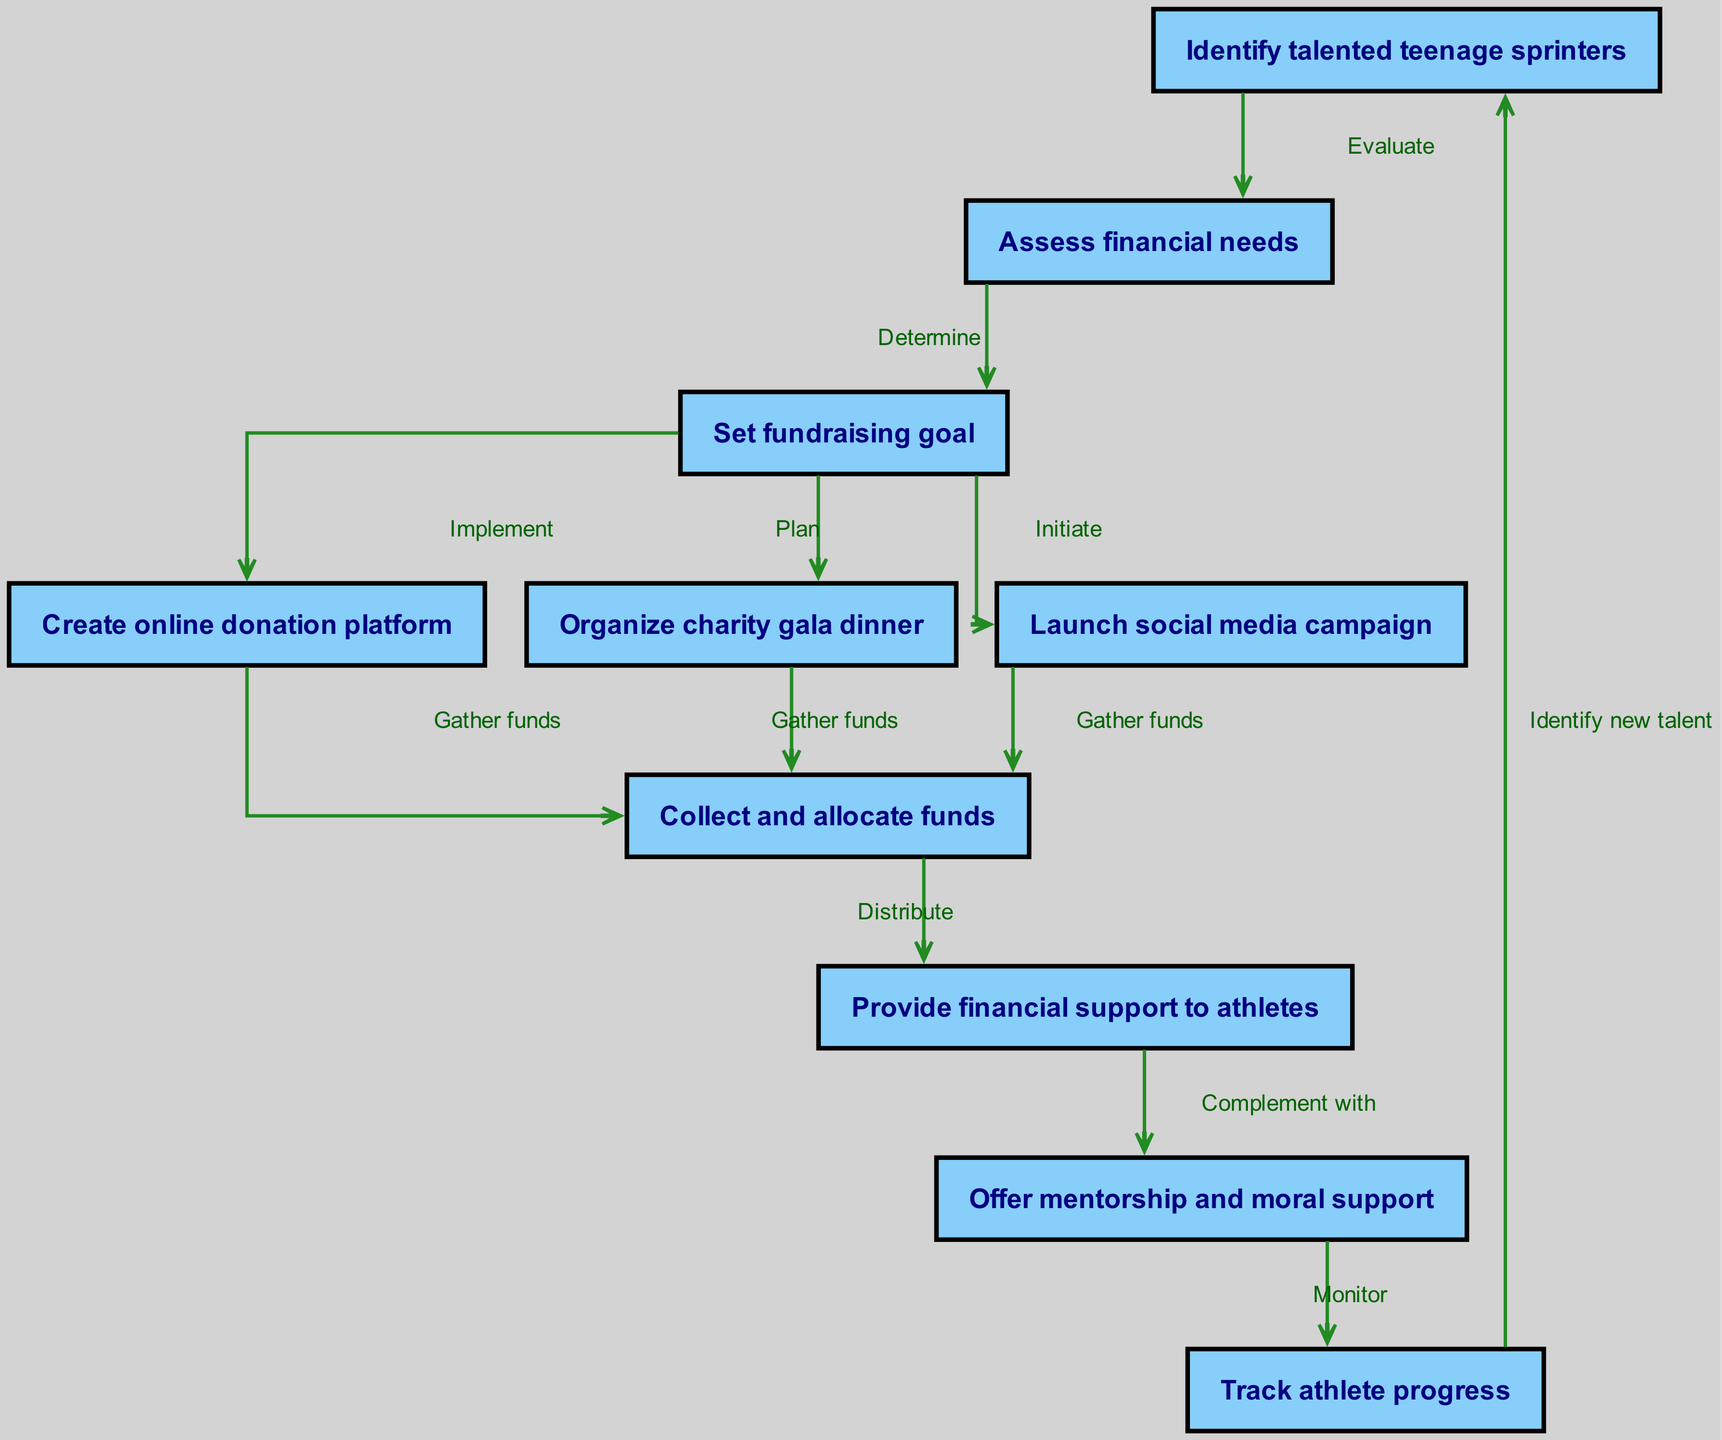What is the first step in the fundraising campaign workflow? The first node in the diagram is "Identify talented teenage sprinters," which indicates that this is the initial action in the workflow.
Answer: Identify talented teenage sprinters How many nodes are there in the diagram? By counting the provided nodes, there are a total of 10 nodes listed, representing different stages or actions in the fundraising workflow.
Answer: 10 What is the relationship between "Set fundraising goal" and "Create online donation platform"? The edge from "Set fundraising goal" to "Create online donation platform" is labeled "Implement," indicating that the action of implementing the donation platform follows after setting the fundraising goal.
Answer: Implement What are the actions that contribute to collecting funds? The actions that lead to the collection of funds include "Create online donation platform," "Organize charity gala dinner," and "Launch social media campaign" all leading to "Collect and allocate funds" node.
Answer: Create online donation platform, Organize charity gala dinner, Launch social media campaign What comes after providing financial support to athletes? After "Provide financial support to athletes," the next step is to "Offer mentorship and moral support," as indicated by the directed edge connecting the two nodes.
Answer: Offer mentorship and moral support Which node demonstrates the relationship between monitoring and identifying new talent? The edge from "Track athlete progress" to "Identify new talent" demonstrates this relationship, showing that monitoring athlete progress leads back to the identification of new talent.
Answer: Track athlete progress to Identify new talent What is the purpose of the "Assess financial needs" node? The purpose of "Assess financial needs" is to determine the financial requirements necessary to support the identified athletes, acting as a crucial step between identifying talent and setting a fundraising goal.
Answer: Determine financial requirements How do we track athlete progress in this workflow? Athlete progress is tracked through the "Track athlete progress" node, which is connected to the mentorship and talent identification nodes, showing its role in the ongoing process of support and improvement.
Answer: Track athlete progress Which node is directly connected to "Collect and allocate funds"? The nodes that are directly connected to "Collect and allocate funds" are "Create online donation platform," "Organize charity gala dinner," and "Launch social media campaign," all of which contribute to gathering the funds needed.
Answer: Create online donation platform, Organize charity gala dinner, Launch social media campaign 